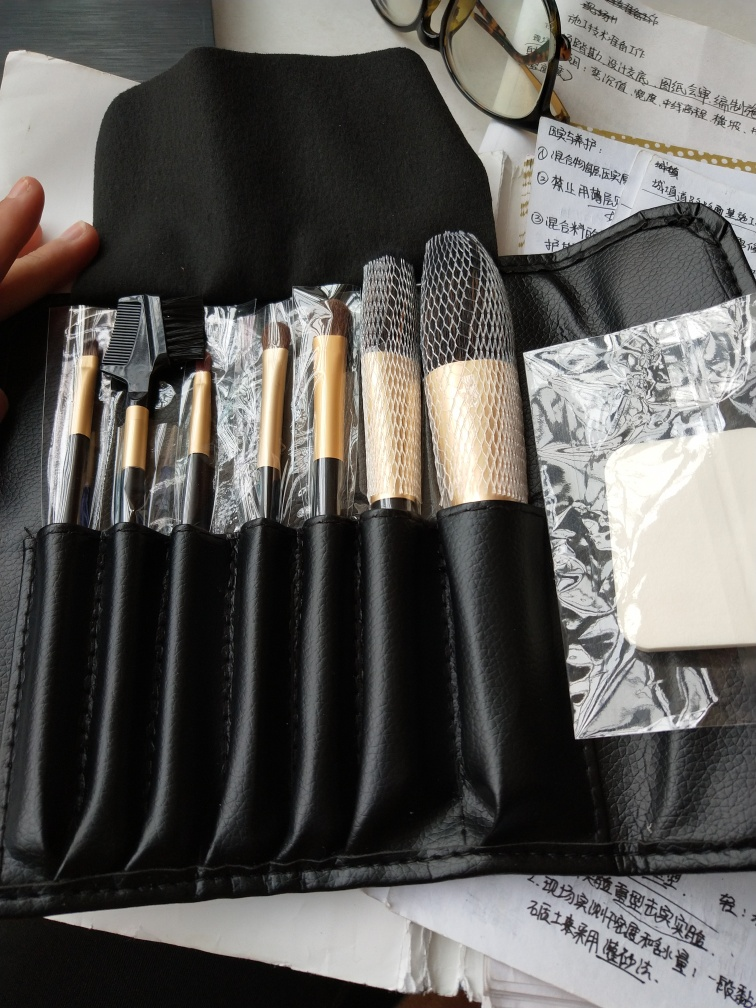There seems to be some document or paperwork under the brush case, what purpose might it serve? While the specific content of the papers isn't fully legible in the image, they seem to contain printed Chinese text, which might be related to business, study, or personal matters. Given their proximity to the personal items like makeup brushes and a spectacle case, these documents could possibly be notes or reminders related to the individual's daily activities or work. 